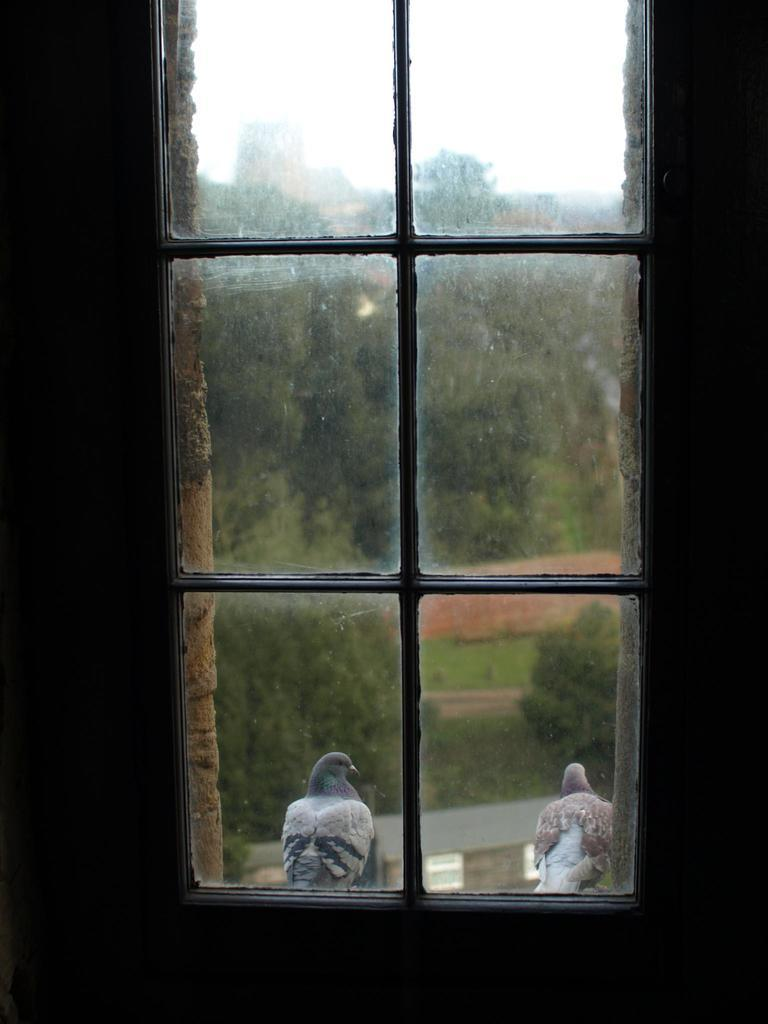What type of structure is present in the image? There is a glass window in the image. What can be seen through the window? Pigeons and trees are visible through the window. Where is the cabbage growing in the image? There is no cabbage present in the image. Can you see a tiger through the window in the image? No, there is no tiger visible through the window in the image. 